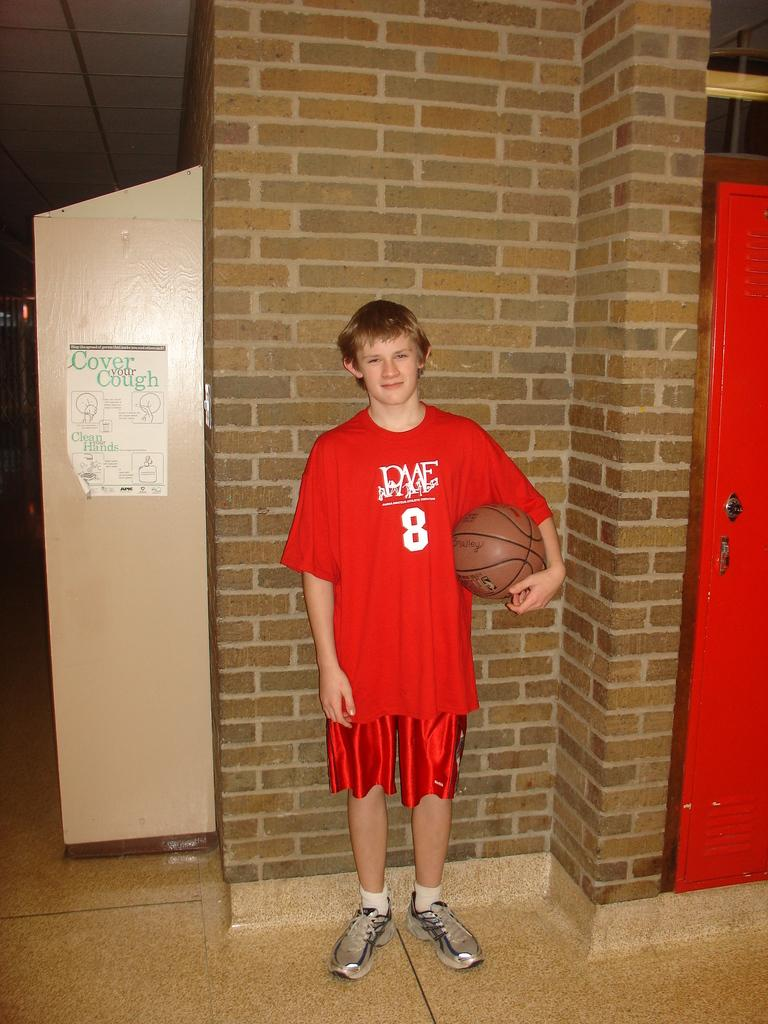<image>
Describe the image concisely. a boy wearing a red shirt with the number 8 on it 